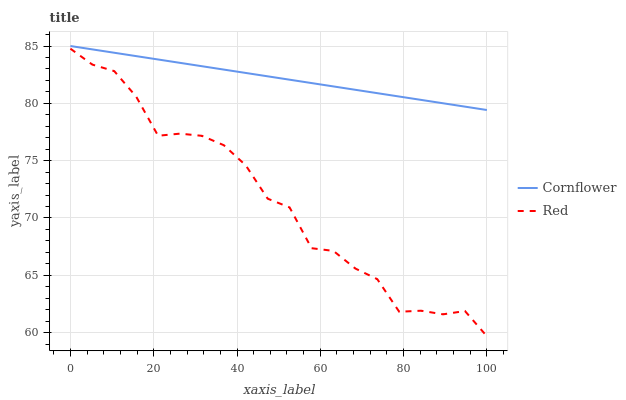Does Red have the minimum area under the curve?
Answer yes or no. Yes. Does Cornflower have the maximum area under the curve?
Answer yes or no. Yes. Does Red have the maximum area under the curve?
Answer yes or no. No. Is Cornflower the smoothest?
Answer yes or no. Yes. Is Red the roughest?
Answer yes or no. Yes. Is Red the smoothest?
Answer yes or no. No. Does Cornflower have the highest value?
Answer yes or no. Yes. Does Red have the highest value?
Answer yes or no. No. Is Red less than Cornflower?
Answer yes or no. Yes. Is Cornflower greater than Red?
Answer yes or no. Yes. Does Red intersect Cornflower?
Answer yes or no. No. 